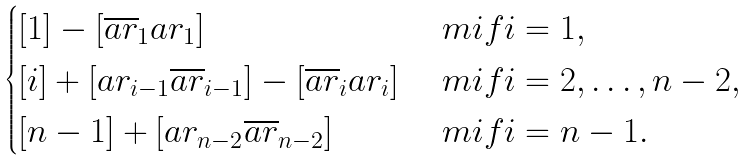<formula> <loc_0><loc_0><loc_500><loc_500>\begin{cases} { [ } 1 ] - [ \overline { a r } _ { 1 } a r _ { 1 } ] & \ m i f i = 1 , \\ { [ } i ] + [ a r _ { i - 1 } \overline { a r } _ { i - 1 } ] - [ \overline { a r } _ { i } a r _ { i } ] & \ m i f i = 2 , \dots , n - 2 , \\ { [ } n - 1 ] + [ a r _ { n - 2 } \overline { a r } _ { n - 2 } ] & \ m i f i = n - 1 . \end{cases}</formula> 